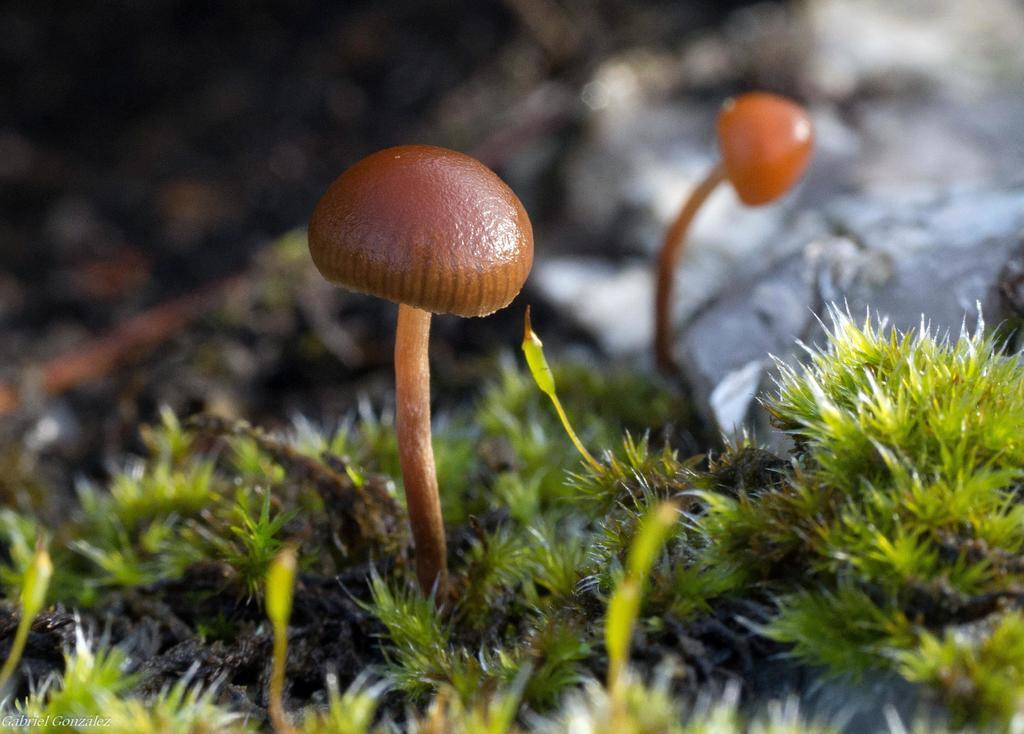What is located in the center of the image? There is grass and mushrooms in the center of the image. What is the color of the grass and mushrooms in the image? The grass and mushrooms are in brown color. Can you see a zipper on the grass in the image? There is no zipper present on the grass in the image. What type of bread is being served by the porter in the image? There is no bread or porter present in the image. 